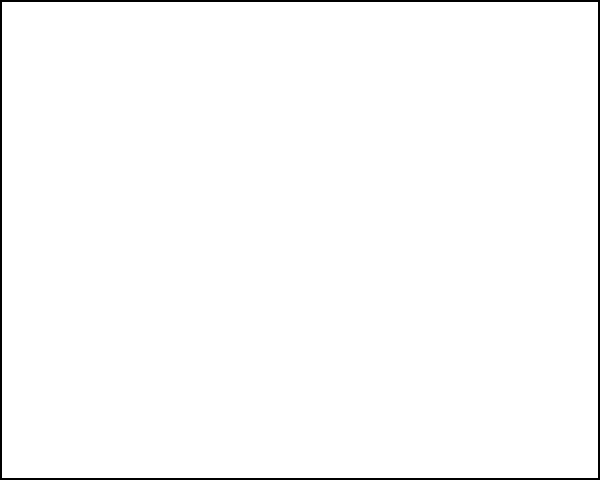In the fetal ultrasound image shown, an abnormal growth is indicated by the red circle. As a healthcare equipment sales professional specializing in prenatal testing tools, what key feature would you highlight to clinicians about advanced ultrasound systems that can aid in the early detection of such abnormalities? To answer this question, we need to consider the advanced features of modern ultrasound systems that are particularly relevant for detecting fetal abnormalities:

1. High-resolution imaging: Advanced ultrasound systems offer significantly improved image resolution compared to older models. This allows for clearer visualization of fetal structures and potential abnormalities.

2. 3D/4D imaging capabilities: These technologies provide more detailed views of the fetus, allowing for better assessment of structural abnormalities.

3. Color Doppler: This feature helps in assessing blood flow, which can be crucial in identifying certain types of abnormalities, particularly those related to the heart or blood vessels.

4. Artificial Intelligence (AI) integration: Some cutting-edge systems incorporate AI algorithms that can assist in identifying potential abnormalities, serving as a "second set of eyes" for clinicians.

5. Elastography: This technique can help differentiate between normal and abnormal tissues based on their stiffness or elasticity.

6. Advanced measurement tools: These allow for precise measurements of fetal structures, which is crucial for identifying size discrepancies that might indicate abnormalities.

Among these features, the most significant for early detection of abnormalities like the one shown in the image is high-resolution imaging. This feature directly impacts the ability to visualize small structures and subtle changes that might indicate an abnormality early in its development.
Answer: High-resolution imaging capability 